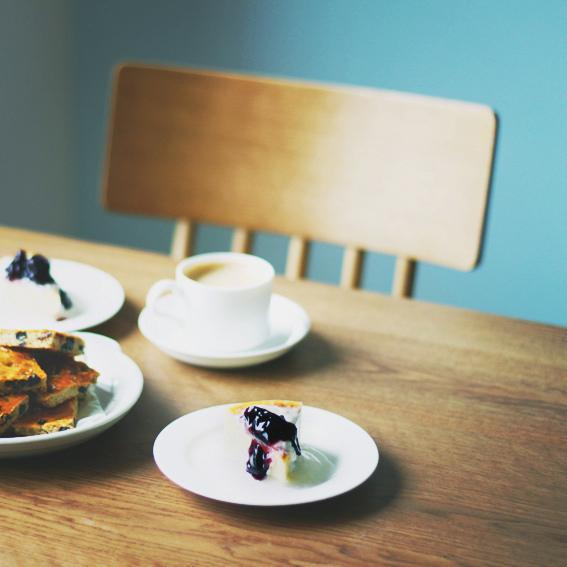What meal is being served?
From the following set of four choices, select the accurate answer to respond to the question.
Options: Dinner, breakfast, afternoon tea, lunch. Afternoon tea. 